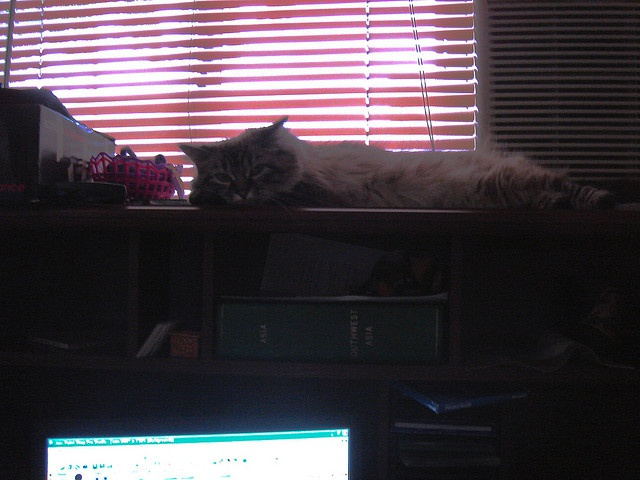Describe the objects in this image and their specific colors. I can see cat in lavender, black, and gray tones, tv in lavender, white, turquoise, navy, and black tones, laptop in lavender, white, turquoise, and cyan tones, book in black and lavender tones, and book in lavender, black, navy, darkblue, and blue tones in this image. 